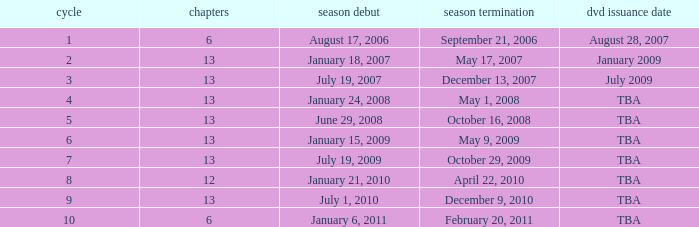Which season had fewer than 13 episodes and aired its season finale on February 20, 2011? 1.0. 